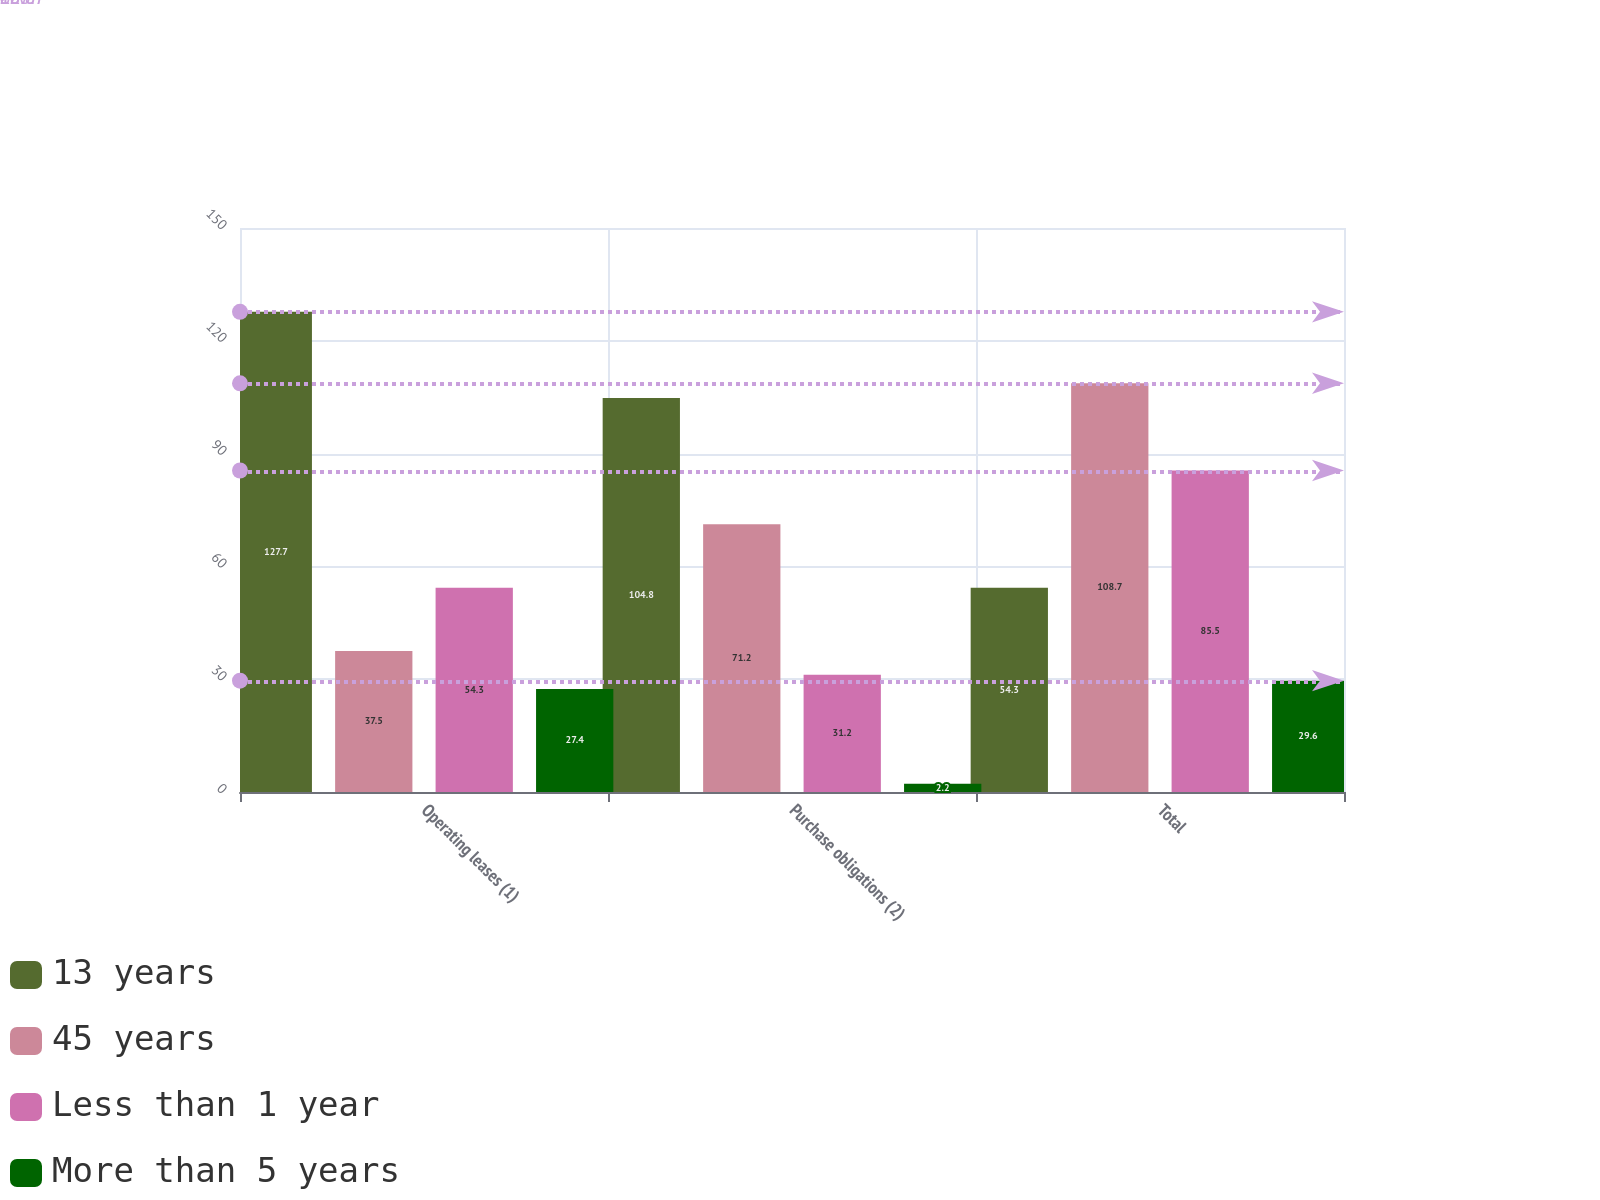<chart> <loc_0><loc_0><loc_500><loc_500><stacked_bar_chart><ecel><fcel>Operating leases (1)<fcel>Purchase obligations (2)<fcel>Total<nl><fcel>13 years<fcel>127.7<fcel>104.8<fcel>54.3<nl><fcel>45 years<fcel>37.5<fcel>71.2<fcel>108.7<nl><fcel>Less than 1 year<fcel>54.3<fcel>31.2<fcel>85.5<nl><fcel>More than 5 years<fcel>27.4<fcel>2.2<fcel>29.6<nl></chart> 